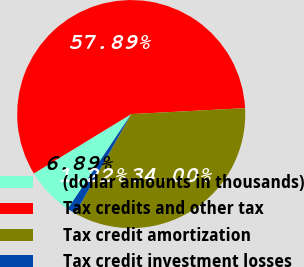Convert chart. <chart><loc_0><loc_0><loc_500><loc_500><pie_chart><fcel>(dollar amounts in thousands)<fcel>Tax credits and other tax<fcel>Tax credit amortization<fcel>Tax credit investment losses<nl><fcel>6.89%<fcel>57.89%<fcel>34.0%<fcel>1.22%<nl></chart> 